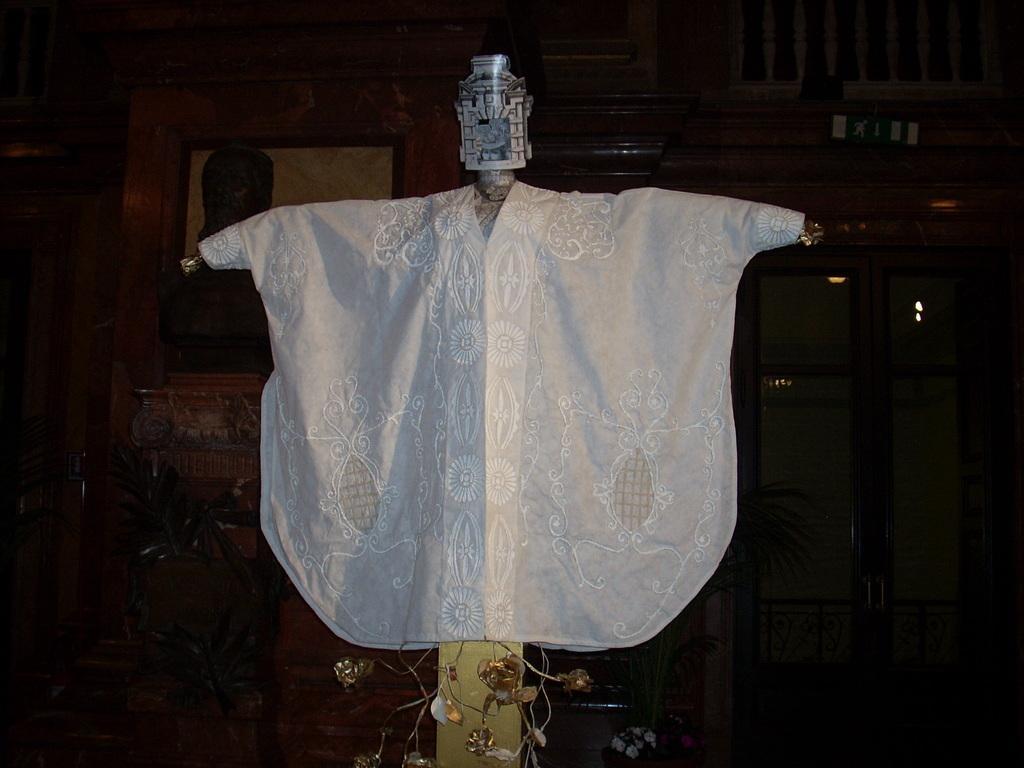How would you summarize this image in a sentence or two? In this image we can see a pole with a cloth and an object on it, in the background, we can see some potted plants, photo frame, cupboard and the wall. 